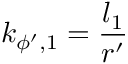Convert formula to latex. <formula><loc_0><loc_0><loc_500><loc_500>k _ { \phi ^ { \prime } , 1 } = \frac { l _ { 1 } } { r ^ { \prime } }</formula> 